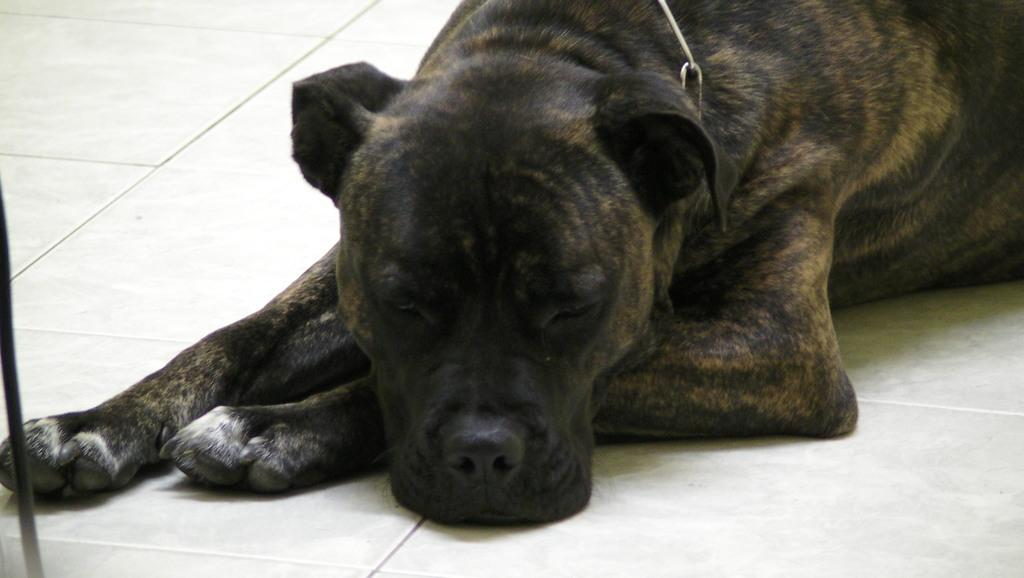What type of animal is in the image? There is a dog in the image. Where is the dog located in the image? The dog is in the center of the image. What surface is the dog on in the image? The dog is on the floor in the image. What type of soda is the dog drinking in the image? There is no soda present in the image; the dog is on the floor and not consuming any beverages. 